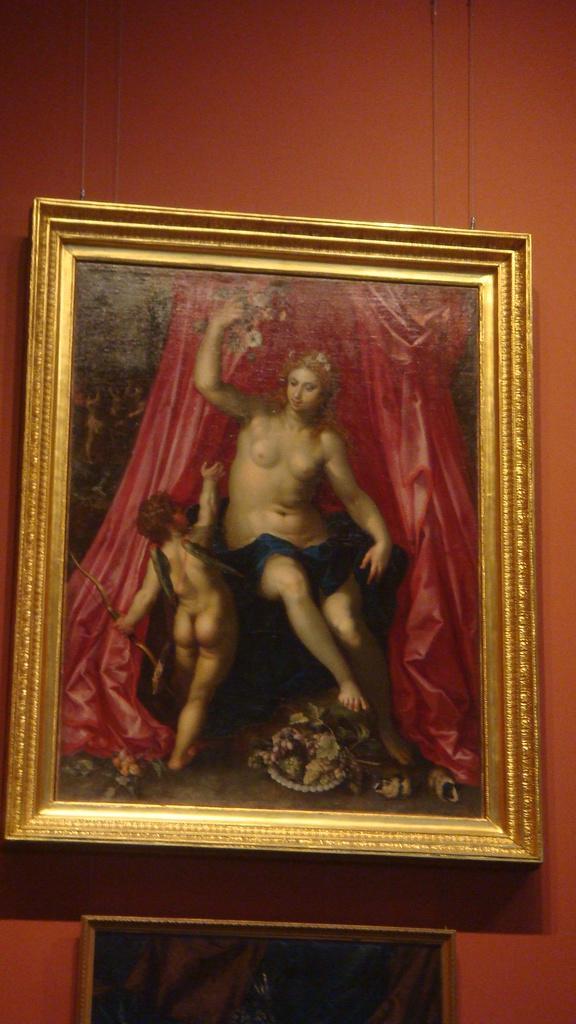How would you summarize this image in a sentence or two? In this picture, we see two photo frames are placed on the brown wall. 